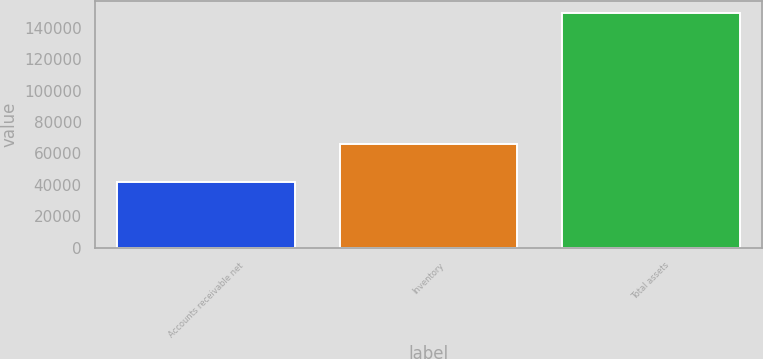<chart> <loc_0><loc_0><loc_500><loc_500><bar_chart><fcel>Accounts receivable net<fcel>Inventory<fcel>Total assets<nl><fcel>41537<fcel>65789<fcel>149550<nl></chart> 